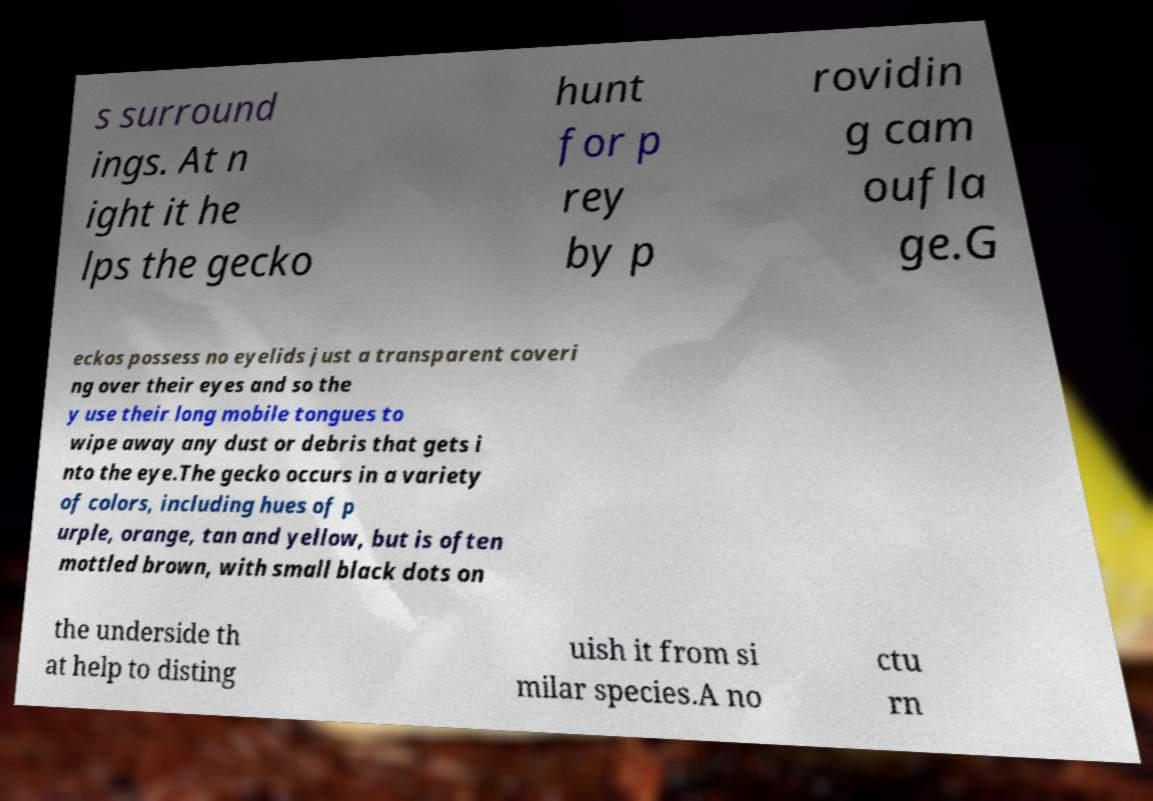Could you extract and type out the text from this image? s surround ings. At n ight it he lps the gecko hunt for p rey by p rovidin g cam oufla ge.G eckos possess no eyelids just a transparent coveri ng over their eyes and so the y use their long mobile tongues to wipe away any dust or debris that gets i nto the eye.The gecko occurs in a variety of colors, including hues of p urple, orange, tan and yellow, but is often mottled brown, with small black dots on the underside th at help to disting uish it from si milar species.A no ctu rn 